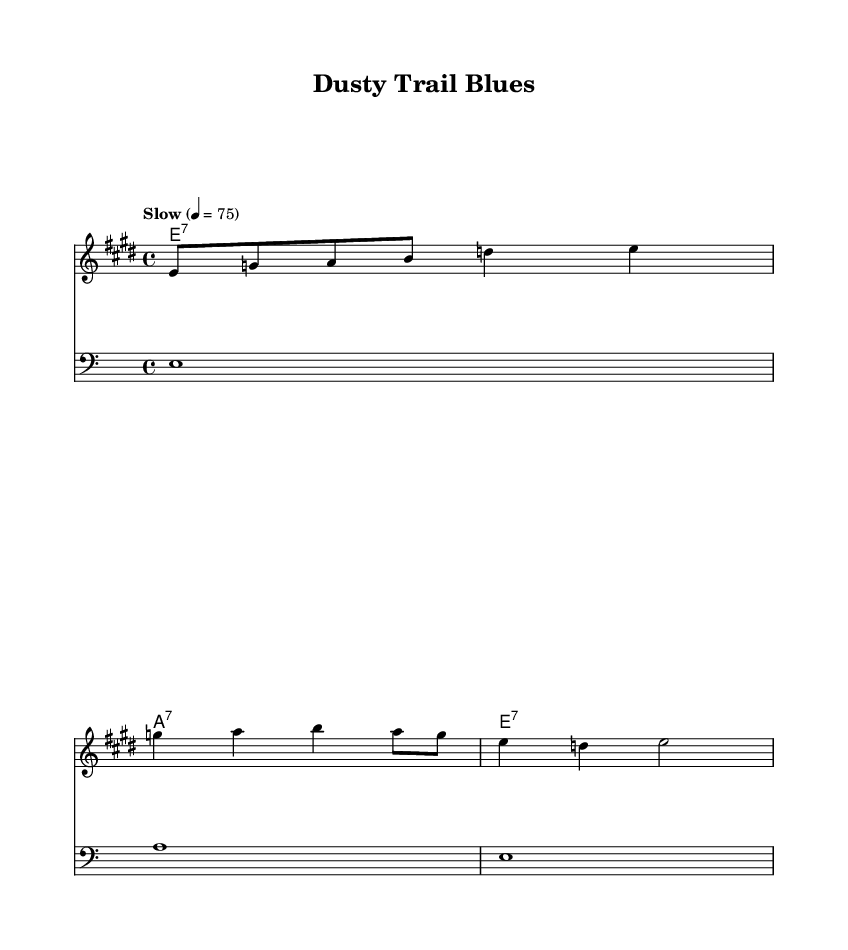What is the key signature of this music? The key signature has four sharps, indicating that the piece is in E major. This is visually confirmed by referencing the key signature positioned at the beginning of the staff.
Answer: E major What is the time signature of this piece? The time signature is represented as a fraction at the beginning of the staff, showing four beats per measure. This indicates a 4/4 time signature, which is common in many music styles, including blues.
Answer: 4/4 What tempo is indicated for this piece? The tempo marking is present at the top of the sheet music, stating "Slow" with a metronome marking of 75 beats per minute. This indicates a relaxed pace suited for blues music.
Answer: Slow 4 = 75 How many measures are in the melody section? By counting the individual phrases in the melody, there are four measures indicated by the musical notation and bar lines, encompassing the rhythmic phrases.
Answer: Four What type of chords are used in the harmonies section? The chord symbols indicate that this piece uses seventh chords, which are characteristic of blues music. Each chord is labeled with a "7" to signify their quality.
Answer: Seventh chords What lyrical theme is depicted in the verse? The lyrics reflect a journey, suggesting a rural and open-world atmosphere aligned with classic blues themes of travel and hardship, indicated by phrases such as "Dusty trail."
Answer: Journey theme How does the bass relate to the melody? The bass line parallels the harmonic progression introduced in the melody, reinforcing the chords being played while providing a foundation for the music. This is common in blues, where the bass supports the overall structure.
Answer: Parallel harmonic foundation 